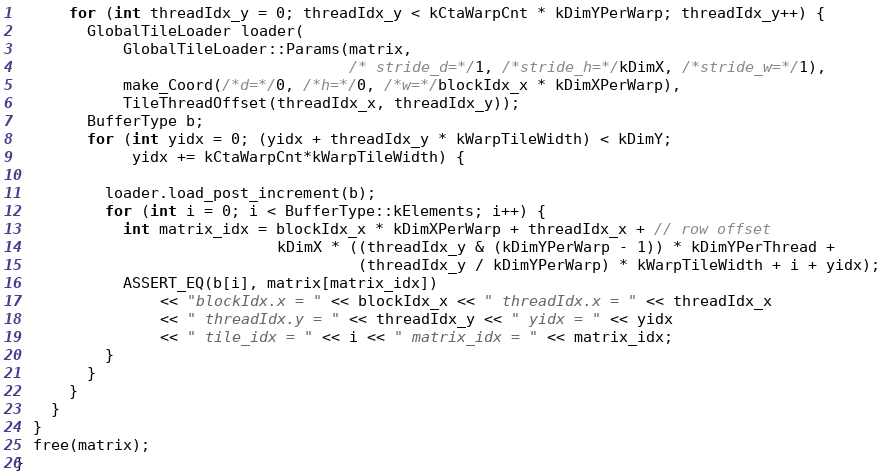<code> <loc_0><loc_0><loc_500><loc_500><_Cuda_>      for (int threadIdx_y = 0; threadIdx_y < kCtaWarpCnt * kDimYPerWarp; threadIdx_y++) {
        GlobalTileLoader loader(
            GlobalTileLoader::Params(matrix,
                                     /* stride_d=*/1, /*stride_h=*/kDimX, /*stride_w=*/1),
            make_Coord(/*d=*/0, /*h=*/0, /*w=*/blockIdx_x * kDimXPerWarp),
            TileThreadOffset(threadIdx_x, threadIdx_y));
        BufferType b;
        for (int yidx = 0; (yidx + threadIdx_y * kWarpTileWidth) < kDimY;
             yidx += kCtaWarpCnt*kWarpTileWidth) {
          
          loader.load_post_increment(b);
          for (int i = 0; i < BufferType::kElements; i++) {
            int matrix_idx = blockIdx_x * kDimXPerWarp + threadIdx_x + // row offset
                             kDimX * ((threadIdx_y & (kDimYPerWarp - 1)) * kDimYPerThread +
                                      (threadIdx_y / kDimYPerWarp) * kWarpTileWidth + i + yidx);
            ASSERT_EQ(b[i], matrix[matrix_idx])
                << "blockIdx.x = " << blockIdx_x << " threadIdx.x = " << threadIdx_x
                << " threadIdx.y = " << threadIdx_y << " yidx = " << yidx
                << " tile_idx = " << i << " matrix_idx = " << matrix_idx;
          }
        }
      }
    }
  }
  free(matrix);
}
</code> 